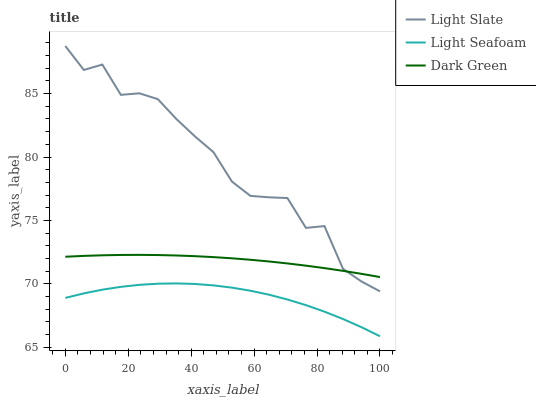Does Light Seafoam have the minimum area under the curve?
Answer yes or no. Yes. Does Light Slate have the maximum area under the curve?
Answer yes or no. Yes. Does Dark Green have the minimum area under the curve?
Answer yes or no. No. Does Dark Green have the maximum area under the curve?
Answer yes or no. No. Is Dark Green the smoothest?
Answer yes or no. Yes. Is Light Slate the roughest?
Answer yes or no. Yes. Is Light Seafoam the smoothest?
Answer yes or no. No. Is Light Seafoam the roughest?
Answer yes or no. No. Does Light Seafoam have the lowest value?
Answer yes or no. Yes. Does Dark Green have the lowest value?
Answer yes or no. No. Does Light Slate have the highest value?
Answer yes or no. Yes. Does Dark Green have the highest value?
Answer yes or no. No. Is Light Seafoam less than Dark Green?
Answer yes or no. Yes. Is Light Slate greater than Light Seafoam?
Answer yes or no. Yes. Does Dark Green intersect Light Slate?
Answer yes or no. Yes. Is Dark Green less than Light Slate?
Answer yes or no. No. Is Dark Green greater than Light Slate?
Answer yes or no. No. Does Light Seafoam intersect Dark Green?
Answer yes or no. No. 